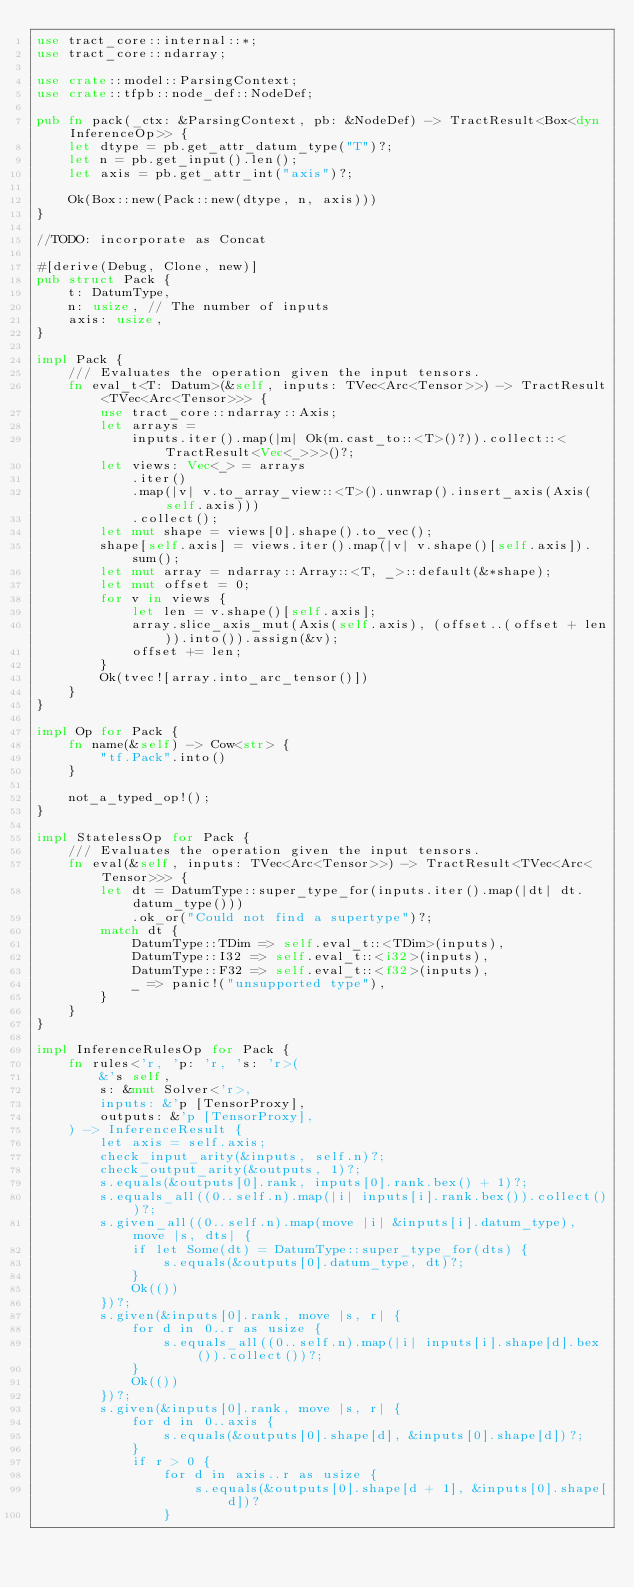<code> <loc_0><loc_0><loc_500><loc_500><_Rust_>use tract_core::internal::*;
use tract_core::ndarray;

use crate::model::ParsingContext;
use crate::tfpb::node_def::NodeDef;

pub fn pack(_ctx: &ParsingContext, pb: &NodeDef) -> TractResult<Box<dyn InferenceOp>> {
    let dtype = pb.get_attr_datum_type("T")?;
    let n = pb.get_input().len();
    let axis = pb.get_attr_int("axis")?;

    Ok(Box::new(Pack::new(dtype, n, axis)))
}

//TODO: incorporate as Concat

#[derive(Debug, Clone, new)]
pub struct Pack {
    t: DatumType,
    n: usize, // The number of inputs
    axis: usize,
}

impl Pack {
    /// Evaluates the operation given the input tensors.
    fn eval_t<T: Datum>(&self, inputs: TVec<Arc<Tensor>>) -> TractResult<TVec<Arc<Tensor>>> {
        use tract_core::ndarray::Axis;
        let arrays =
            inputs.iter().map(|m| Ok(m.cast_to::<T>()?)).collect::<TractResult<Vec<_>>>()?;
        let views: Vec<_> = arrays
            .iter()
            .map(|v| v.to_array_view::<T>().unwrap().insert_axis(Axis(self.axis)))
            .collect();
        let mut shape = views[0].shape().to_vec();
        shape[self.axis] = views.iter().map(|v| v.shape()[self.axis]).sum();
        let mut array = ndarray::Array::<T, _>::default(&*shape);
        let mut offset = 0;
        for v in views {
            let len = v.shape()[self.axis];
            array.slice_axis_mut(Axis(self.axis), (offset..(offset + len)).into()).assign(&v);
            offset += len;
        }
        Ok(tvec![array.into_arc_tensor()])
    }
}

impl Op for Pack {
    fn name(&self) -> Cow<str> {
        "tf.Pack".into()
    }

    not_a_typed_op!();
}

impl StatelessOp for Pack {
    /// Evaluates the operation given the input tensors.
    fn eval(&self, inputs: TVec<Arc<Tensor>>) -> TractResult<TVec<Arc<Tensor>>> {
        let dt = DatumType::super_type_for(inputs.iter().map(|dt| dt.datum_type()))
            .ok_or("Could not find a supertype")?;
        match dt {
            DatumType::TDim => self.eval_t::<TDim>(inputs),
            DatumType::I32 => self.eval_t::<i32>(inputs),
            DatumType::F32 => self.eval_t::<f32>(inputs),
            _ => panic!("unsupported type"),
        }
    }
}

impl InferenceRulesOp for Pack {
    fn rules<'r, 'p: 'r, 's: 'r>(
        &'s self,
        s: &mut Solver<'r>,
        inputs: &'p [TensorProxy],
        outputs: &'p [TensorProxy],
    ) -> InferenceResult {
        let axis = self.axis;
        check_input_arity(&inputs, self.n)?;
        check_output_arity(&outputs, 1)?;
        s.equals(&outputs[0].rank, inputs[0].rank.bex() + 1)?;
        s.equals_all((0..self.n).map(|i| inputs[i].rank.bex()).collect())?;
        s.given_all((0..self.n).map(move |i| &inputs[i].datum_type), move |s, dts| {
            if let Some(dt) = DatumType::super_type_for(dts) {
                s.equals(&outputs[0].datum_type, dt)?;
            }
            Ok(())
        })?;
        s.given(&inputs[0].rank, move |s, r| {
            for d in 0..r as usize {
                s.equals_all((0..self.n).map(|i| inputs[i].shape[d].bex()).collect())?;
            }
            Ok(())
        })?;
        s.given(&inputs[0].rank, move |s, r| {
            for d in 0..axis {
                s.equals(&outputs[0].shape[d], &inputs[0].shape[d])?;
            }
            if r > 0 {
                for d in axis..r as usize {
                    s.equals(&outputs[0].shape[d + 1], &inputs[0].shape[d])?
                }</code> 